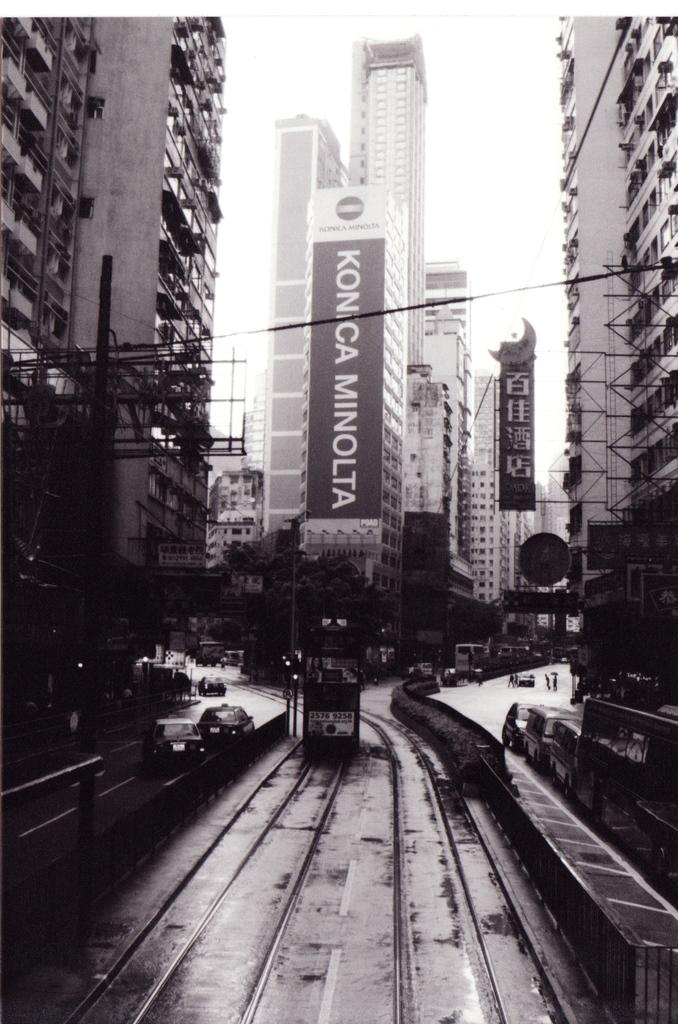<image>
Offer a succinct explanation of the picture presented. an old black and white scene of a street car in front of a Minolta billboard 